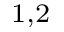Convert formula to latex. <formula><loc_0><loc_0><loc_500><loc_500>^ { 1 , 2 }</formula> 